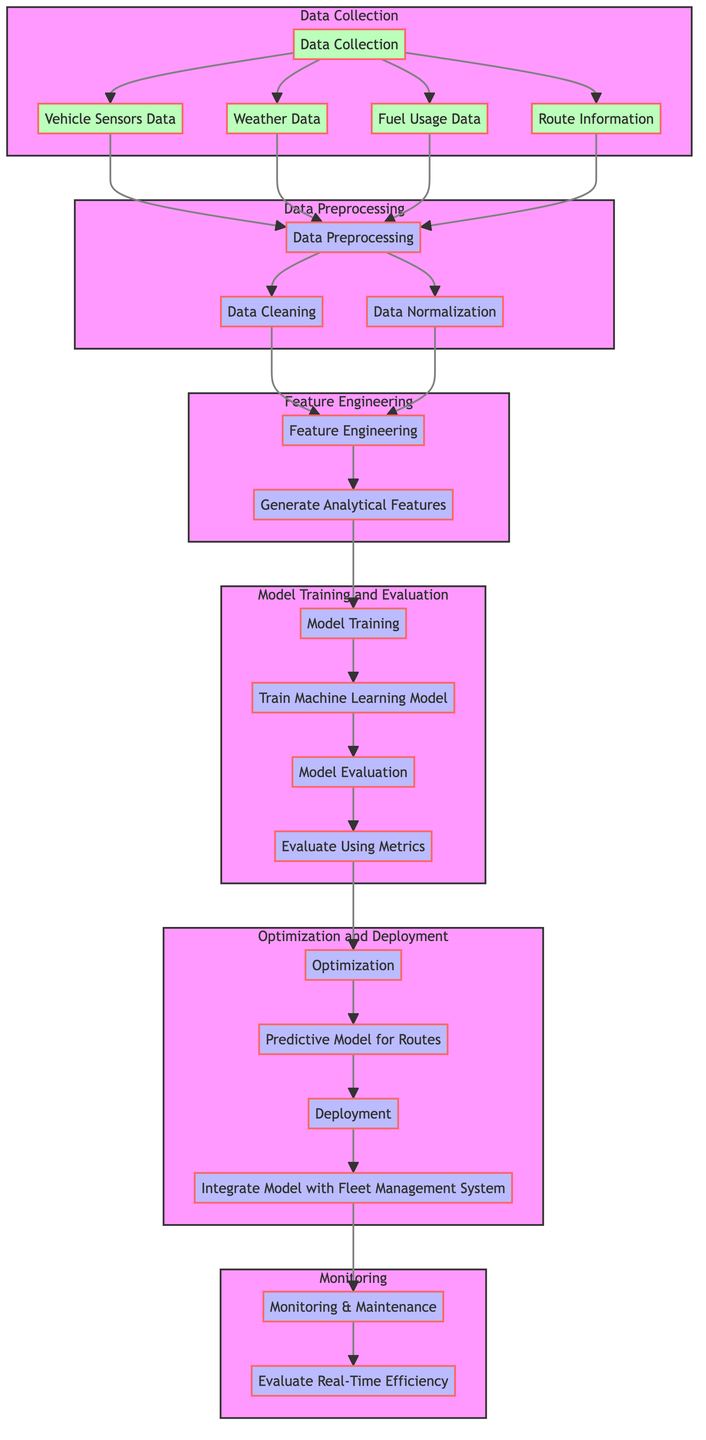What are the four data sources in the Data Collection subgraph? The Data Collection subgraph shows four data sources connected to it: Vehicle Sensors Data, Weather Data, Fuel Usage Data, and Route Information.
Answer: Vehicle Sensors Data, Weather Data, Fuel Usage Data, Route Information How many subprocesses are there in the Model Training and Evaluation section? In the Model Training and Evaluation subgraph, there are two subprocesses: Train Machine Learning Model and Evaluate Using Metrics.
Answer: Two What comes after Data Preprocessing in the flow of the diagram? After the Data Preprocessing subgraph, the next process shown in the diagram is Feature Engineering, specifically leading to Generate Analytical Features.
Answer: Feature Engineering How does Monitoring & Maintenance connect to the diagram? Monitoring & Maintenance connects to the process through Evaluate Real-Time Efficiency, and it is linked to the Deployment stage. It indicates real-time usage of the optimized model.
Answer: Connected through Evaluate Real-Time Efficiency What is the main goal of the Optimization step according to the diagram? The main goal of the Optimization step is to create a Predictive Model for Routes that enhances fuel efficiency. The process flows from the evaluation to optimization.
Answer: Predictive Model for Routes Why do the data sources connect to Data Preprocessing? The data sources (Vehicle Sensors Data, Weather Data, Fuel Usage Data, Route Information) connect to Data Preprocessing because this stage is necessary to clean and normalize the raw data before it can be analyzed or used for feature engineering.
Answer: For cleaning and normalization What are the two main stages after Feature Engineering? The two main stages following Feature Engineering are Model Training and Evaluation, and Optimization and Deployment. This indicates the flow of moving from processed features to model implementation.
Answer: Model Training and Evaluation, Optimization and Deployment Where does the output from Model Evaluation lead to? The output from Model Evaluation leads to the Optimization step, indicating that having a good evaluation metric is crucial for optimizing the predictive routes used in trucking.
Answer: Optimization What type of model is created in the Optimization phase? In the Optimization phase, a Predictive Model for Routes is created, aiming to enhance fuel efficiency by predicting the best routes based on historical and real-time data.
Answer: Predictive Model for Routes 